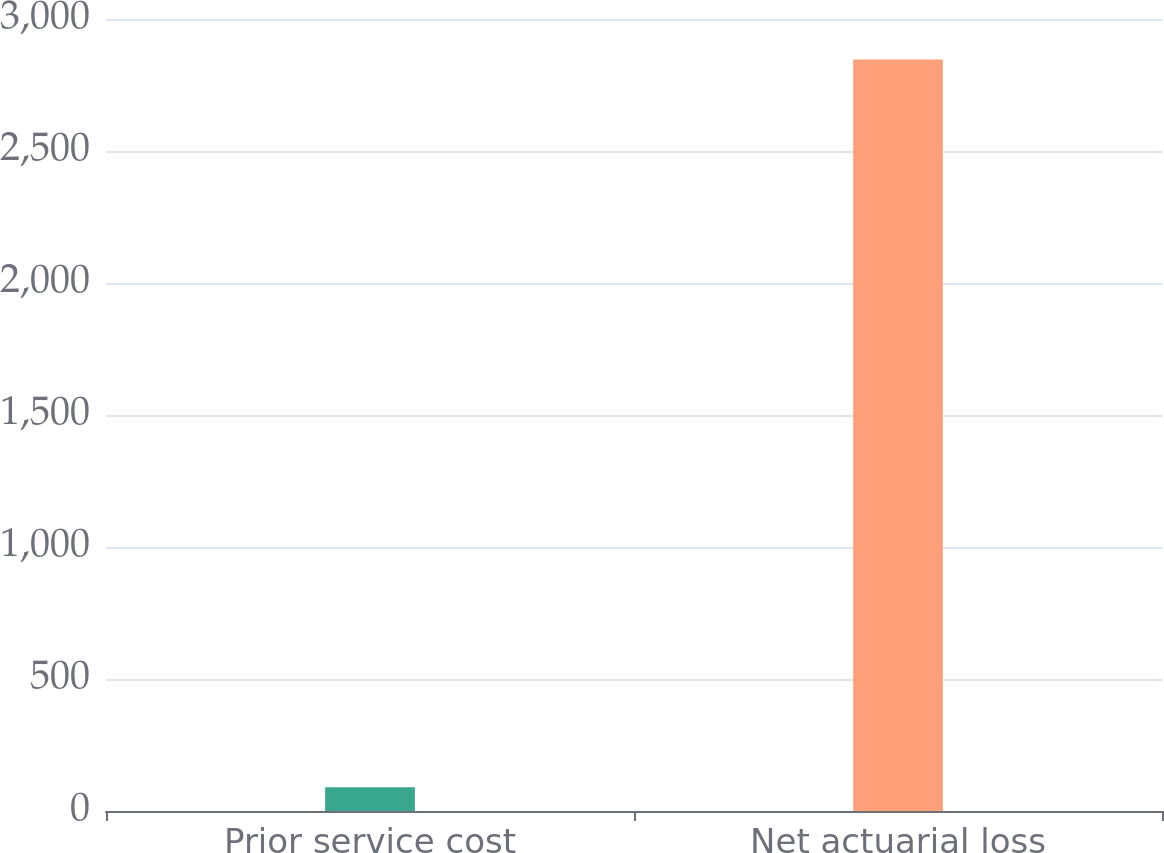Convert chart to OTSL. <chart><loc_0><loc_0><loc_500><loc_500><bar_chart><fcel>Prior service cost<fcel>Net actuarial loss<nl><fcel>90<fcel>2847<nl></chart> 